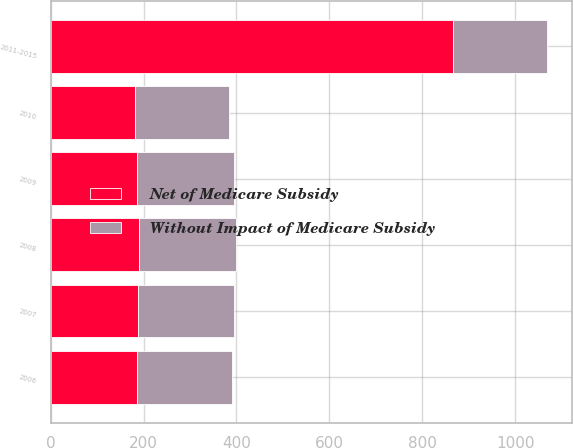<chart> <loc_0><loc_0><loc_500><loc_500><stacked_bar_chart><ecel><fcel>2006<fcel>2007<fcel>2008<fcel>2009<fcel>2010<fcel>2011-2015<nl><fcel>Without Impact of Medicare Subsidy<fcel>205<fcel>207<fcel>210<fcel>208<fcel>203<fcel>203<nl><fcel>Net of Medicare Subsidy<fcel>186<fcel>188<fcel>190<fcel>187<fcel>182<fcel>865<nl></chart> 